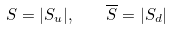<formula> <loc_0><loc_0><loc_500><loc_500>S = | S _ { u } | , \quad \overline { S } = | S _ { d } |</formula> 